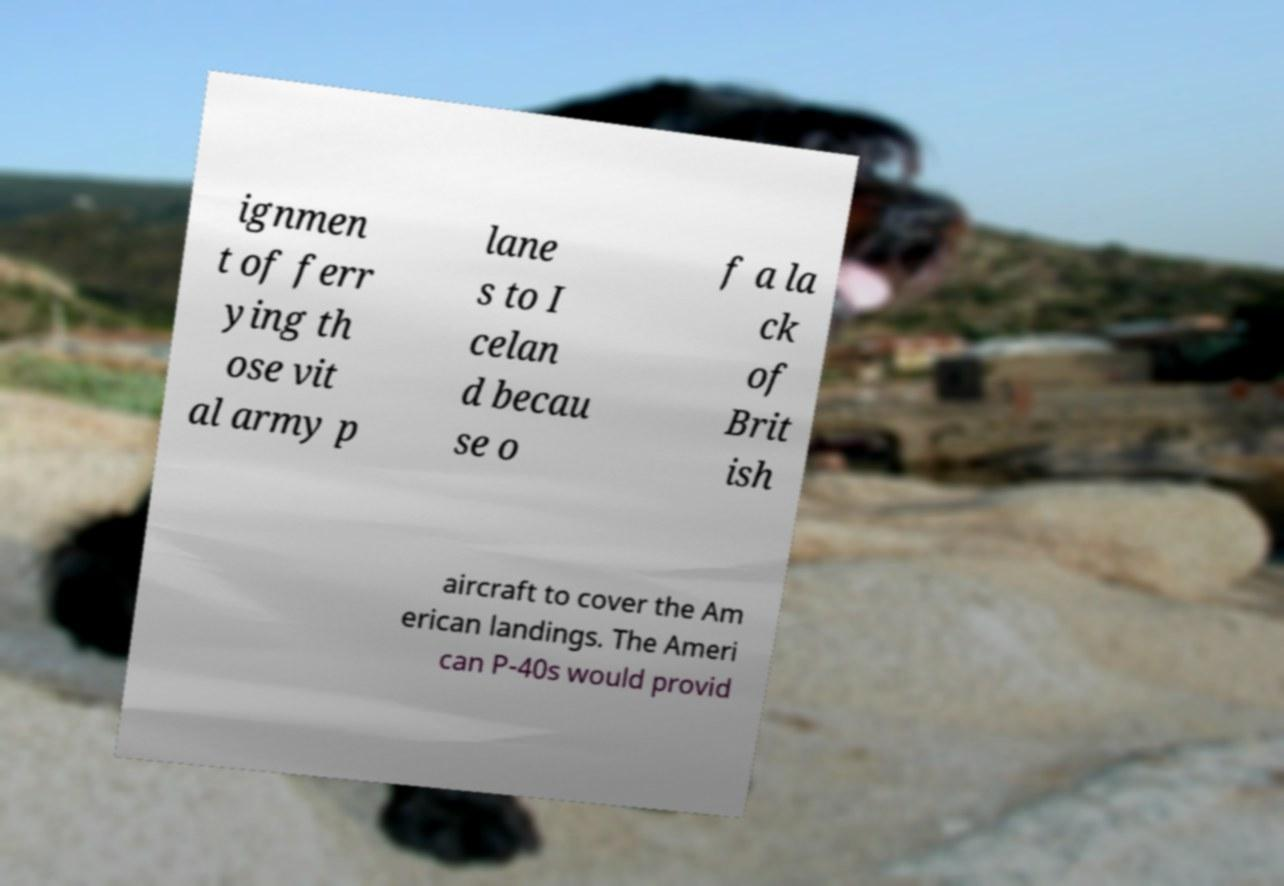Could you extract and type out the text from this image? ignmen t of ferr ying th ose vit al army p lane s to I celan d becau se o f a la ck of Brit ish aircraft to cover the Am erican landings. The Ameri can P-40s would provid 